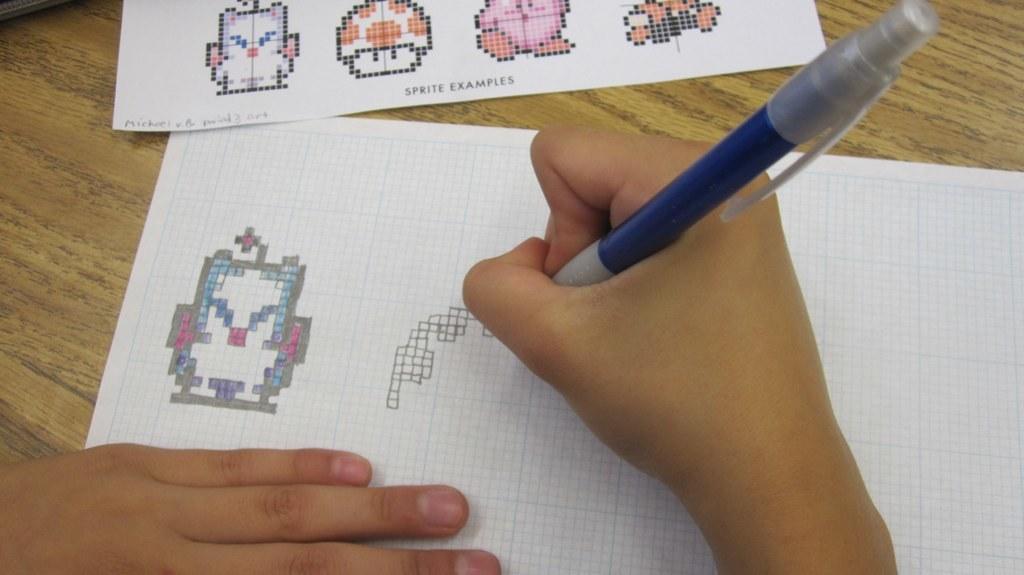In one or two sentences, can you explain what this image depicts? In this picture i can see the person's hand and he is holding a blue pen. At the top i can see two papers which is kept on the table. 